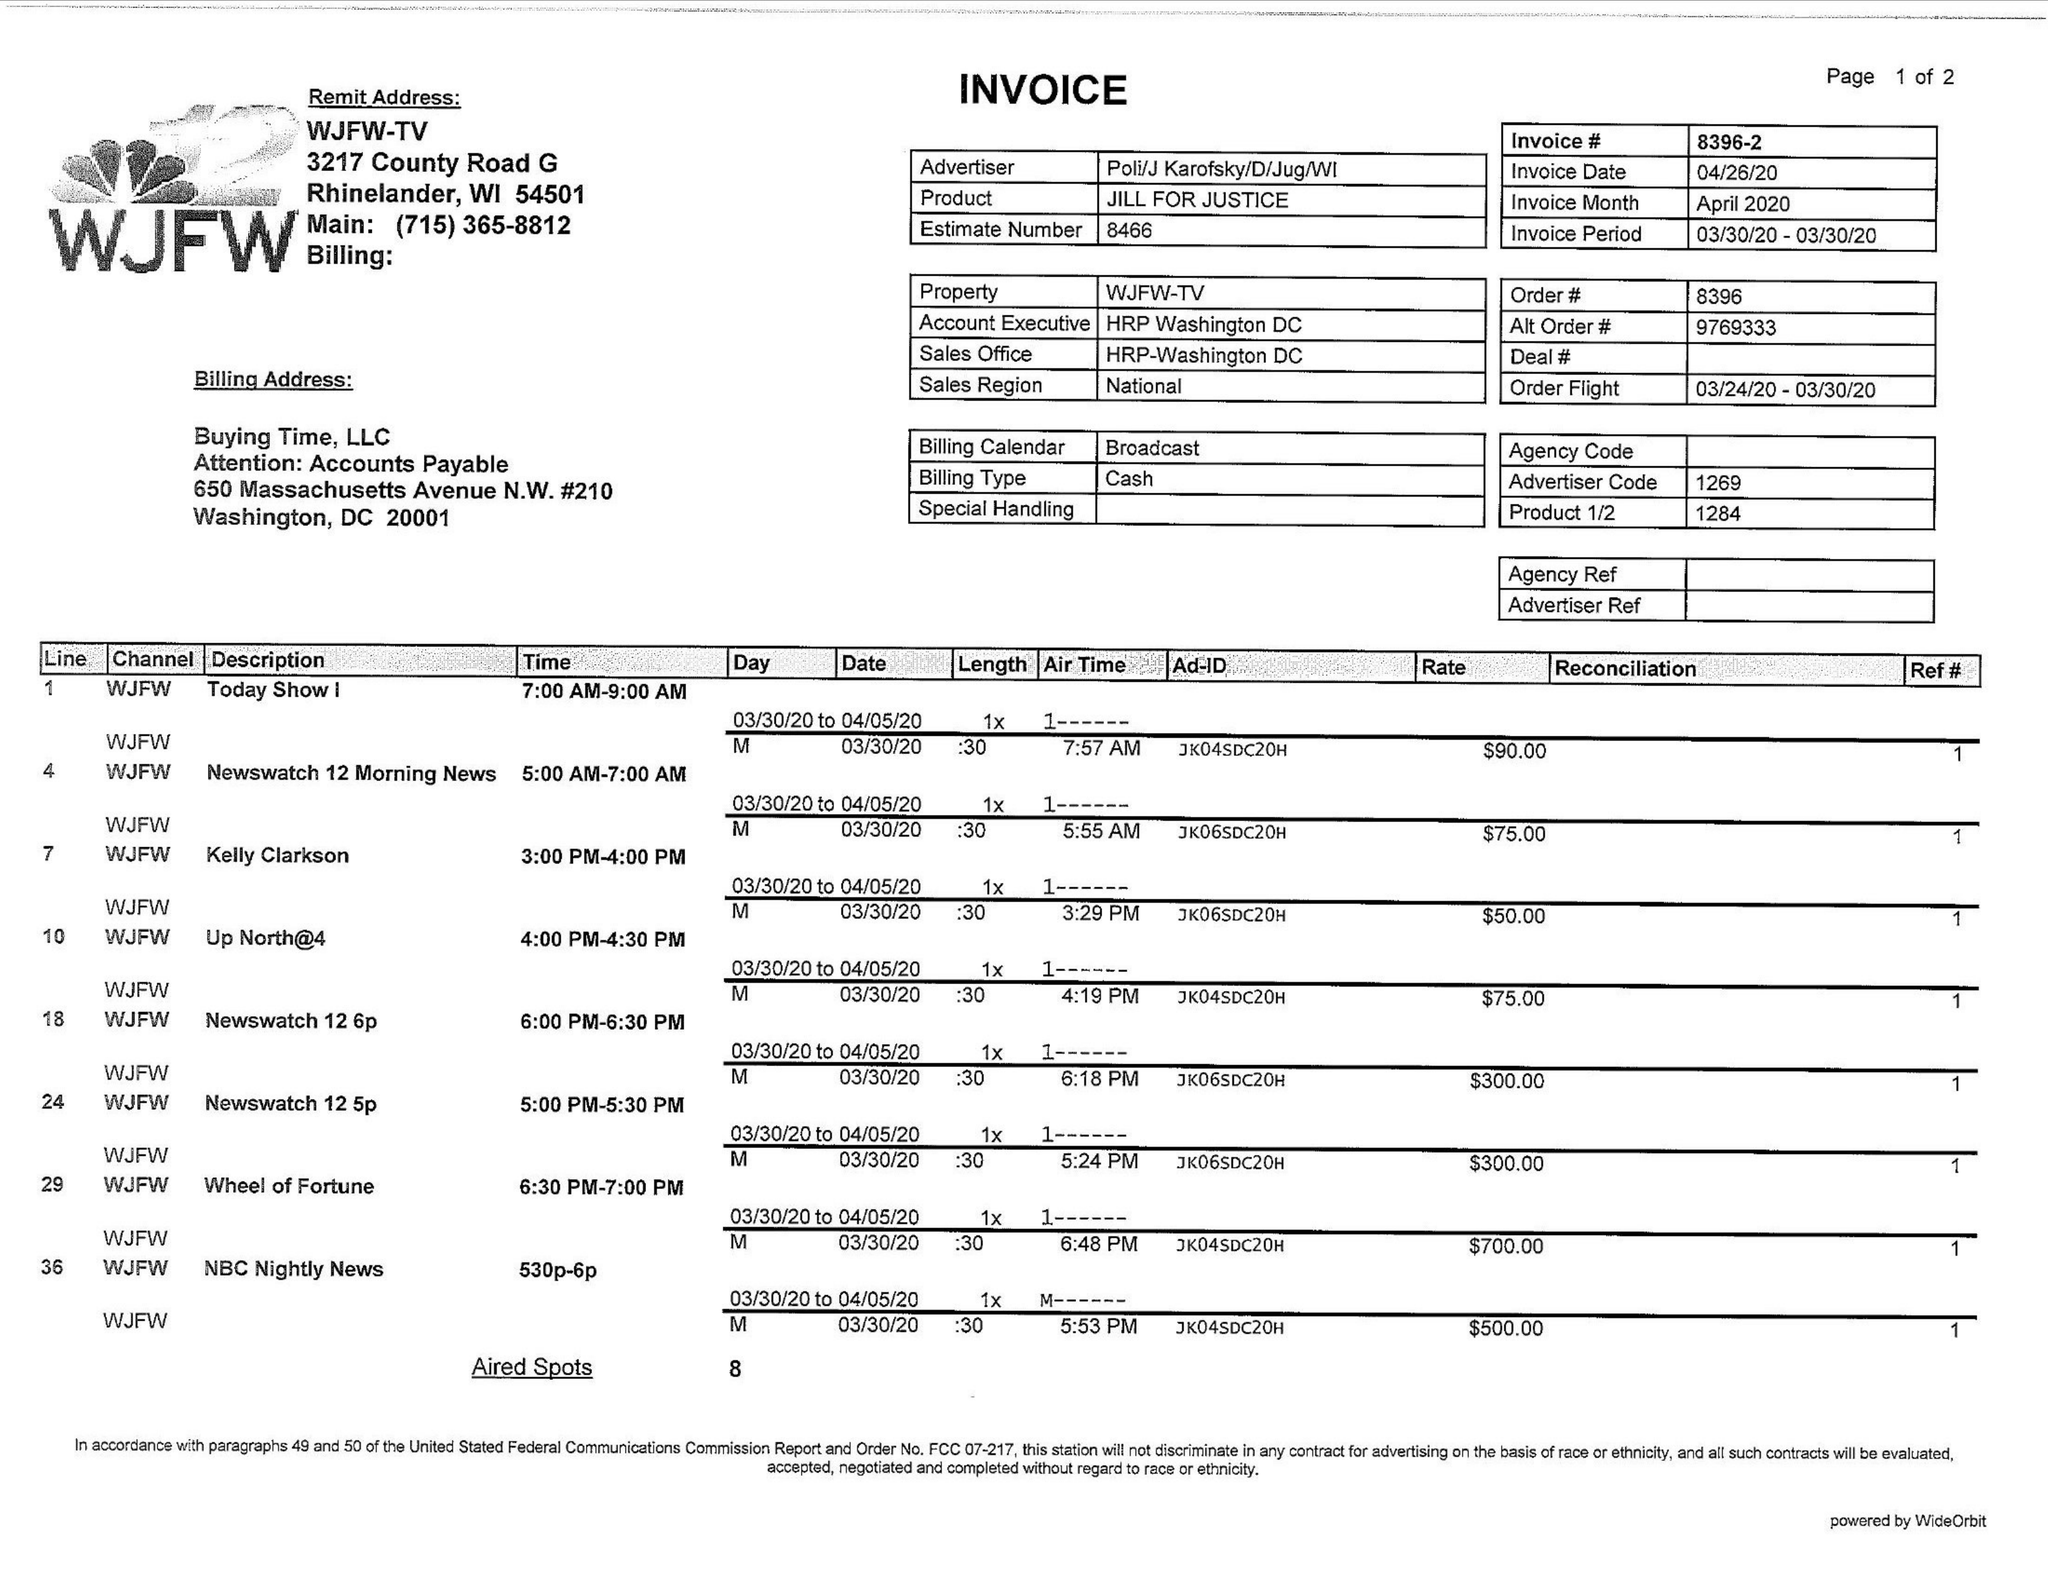What is the value for the flight_from?
Answer the question using a single word or phrase. 03/24/20 